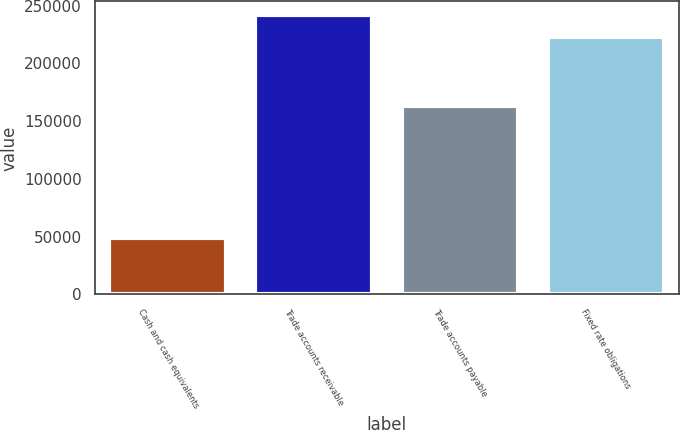Convert chart to OTSL. <chart><loc_0><loc_0><loc_500><loc_500><bar_chart><fcel>Cash and cash equivalents<fcel>Trade accounts receivable<fcel>Trade accounts payable<fcel>Fixed rate obligations<nl><fcel>49245<fcel>241660<fcel>163291<fcel>223260<nl></chart> 